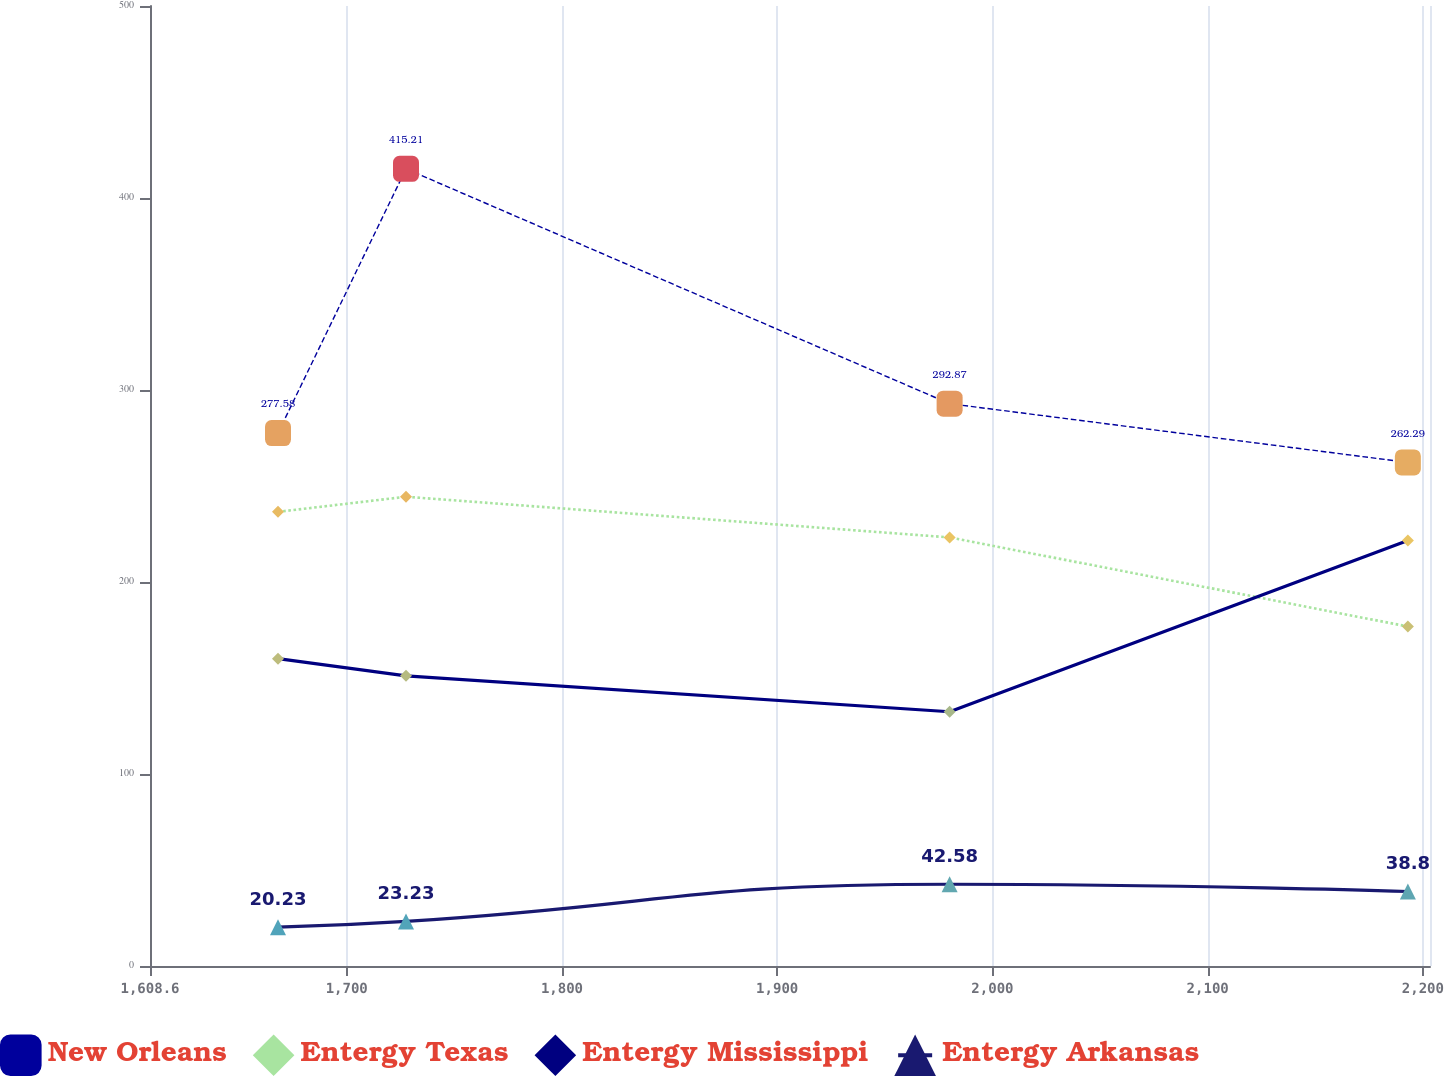Convert chart to OTSL. <chart><loc_0><loc_0><loc_500><loc_500><line_chart><ecel><fcel>New Orleans<fcel>Entergy Texas<fcel>Entergy Mississippi<fcel>Entergy Arkansas<nl><fcel>1668.07<fcel>277.58<fcel>236.55<fcel>160.06<fcel>20.23<nl><fcel>1727.54<fcel>415.21<fcel>244.4<fcel>151.14<fcel>23.23<nl><fcel>1980.11<fcel>292.87<fcel>223.22<fcel>132.41<fcel>42.58<nl><fcel>2193.01<fcel>262.29<fcel>176.83<fcel>221.61<fcel>38.8<nl><fcel>2262.77<fcel>308.16<fcel>163.41<fcel>168.98<fcel>30.45<nl></chart> 